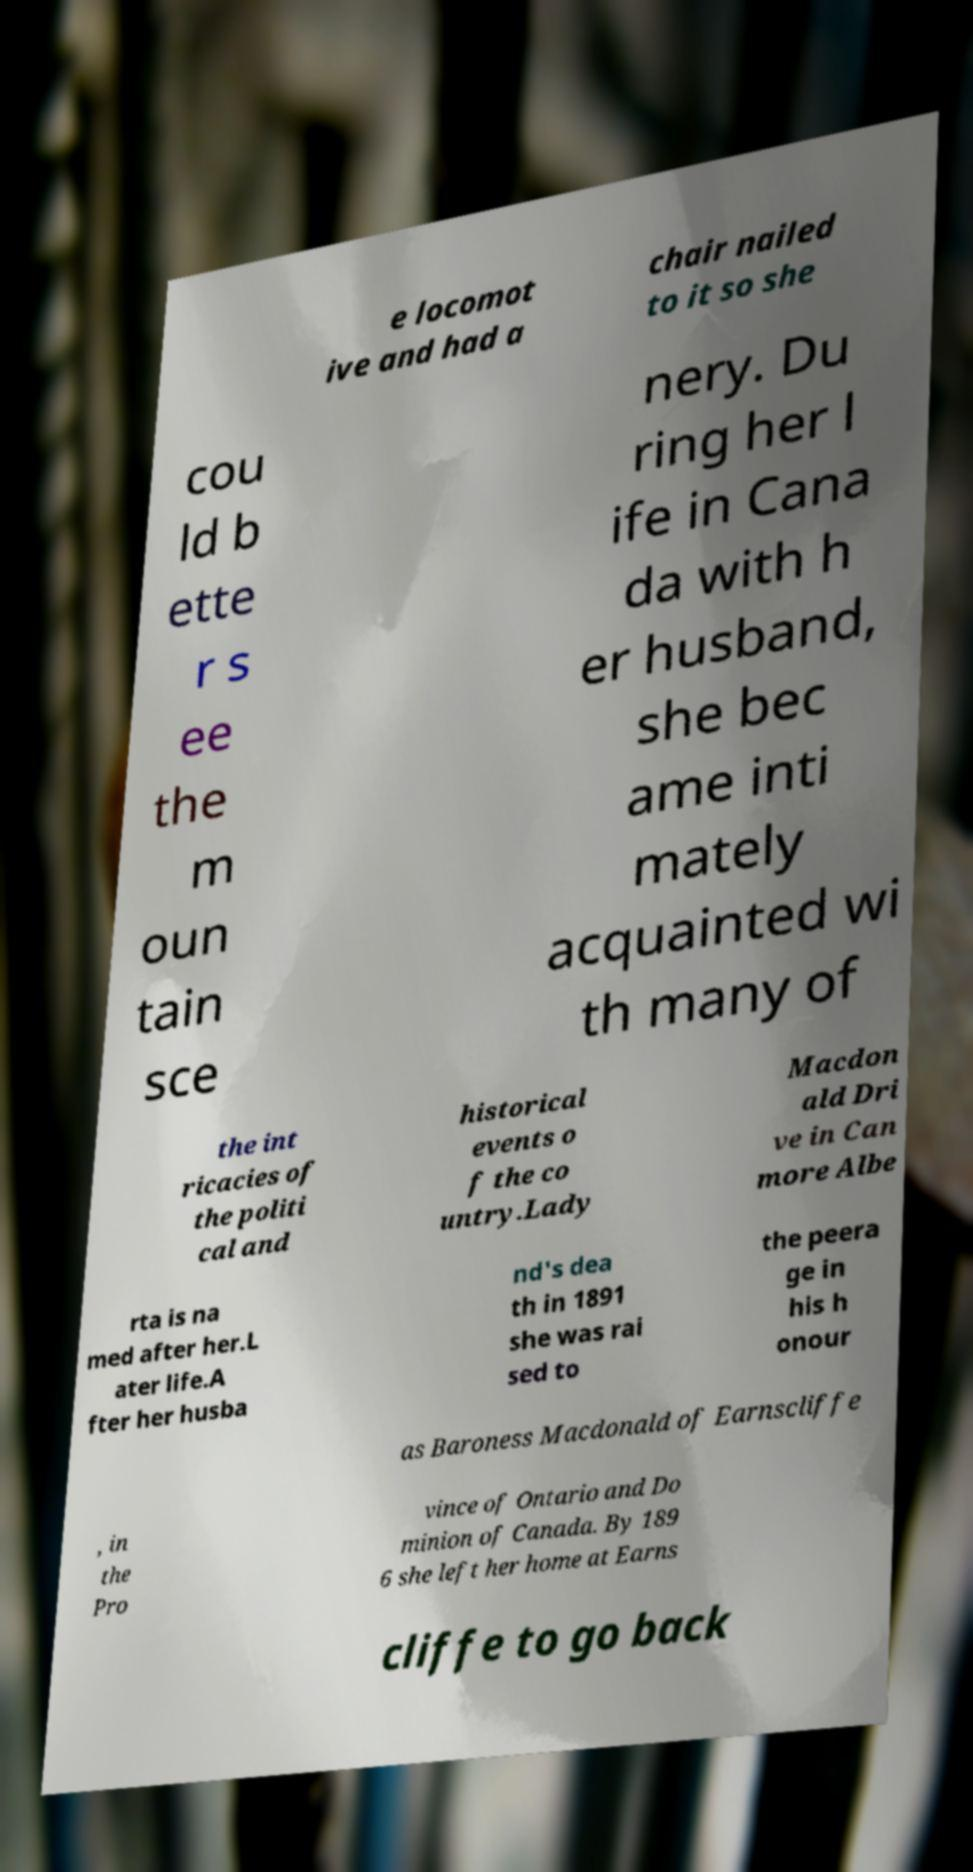What messages or text are displayed in this image? I need them in a readable, typed format. e locomot ive and had a chair nailed to it so she cou ld b ette r s ee the m oun tain sce nery. Du ring her l ife in Cana da with h er husband, she bec ame inti mately acquainted wi th many of the int ricacies of the politi cal and historical events o f the co untry.Lady Macdon ald Dri ve in Can more Albe rta is na med after her.L ater life.A fter her husba nd's dea th in 1891 she was rai sed to the peera ge in his h onour as Baroness Macdonald of Earnscliffe , in the Pro vince of Ontario and Do minion of Canada. By 189 6 she left her home at Earns cliffe to go back 